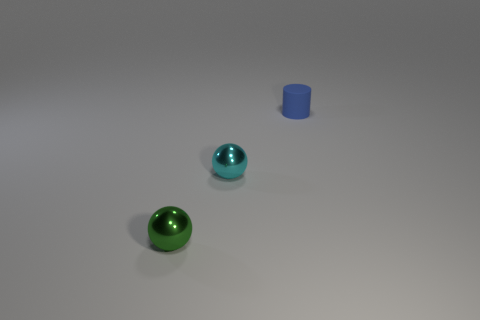What number of other tiny metal things have the same shape as the small cyan shiny thing?
Give a very brief answer. 1. Is there anything else that has the same size as the cyan thing?
Provide a succinct answer. Yes. What size is the shiny thing that is right of the small ball that is in front of the small cyan metallic ball?
Provide a succinct answer. Small. There is a green ball that is the same size as the rubber cylinder; what material is it?
Make the answer very short. Metal. Are there any cylinders made of the same material as the green ball?
Offer a terse response. No. There is a tiny matte thing on the right side of the tiny sphere left of the metallic ball that is right of the tiny green object; what is its color?
Offer a very short reply. Blue. There is a small metallic object that is in front of the small cyan thing; is its color the same as the object behind the small cyan object?
Your answer should be very brief. No. Are there any other things of the same color as the tiny rubber thing?
Ensure brevity in your answer.  No. Are there fewer metallic balls behind the tiny green metallic object than purple spheres?
Ensure brevity in your answer.  No. How many tiny gray cylinders are there?
Ensure brevity in your answer.  0. 